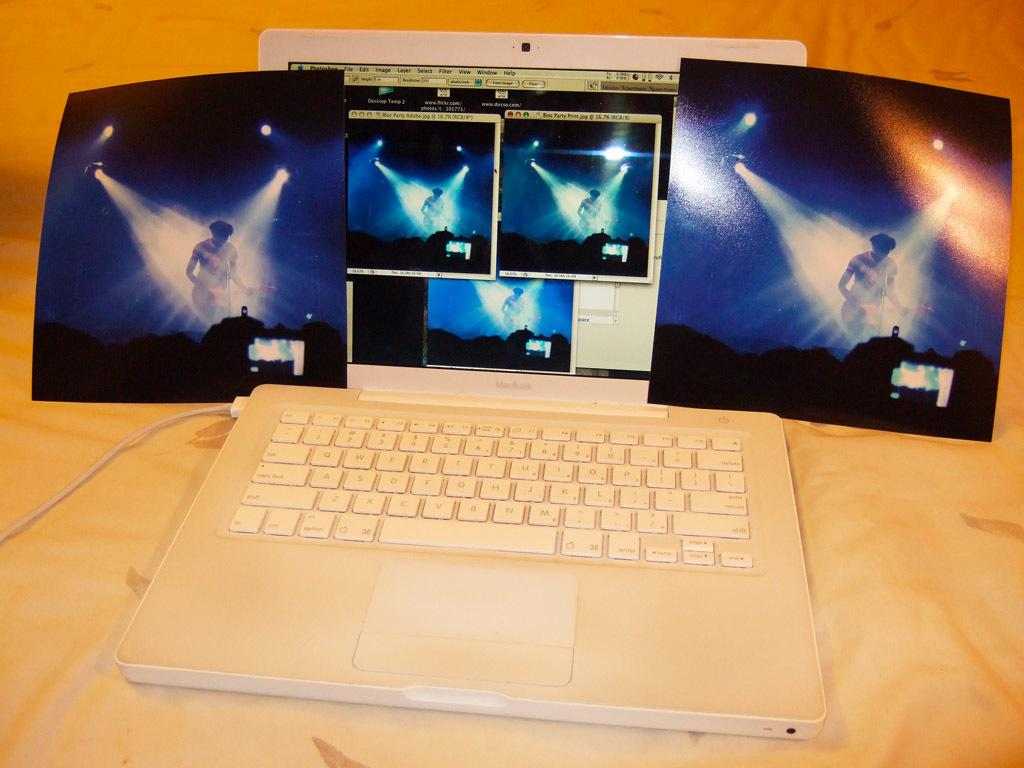<image>
Summarize the visual content of the image. A white MacBook is open and two concert photos are sitting on it. 